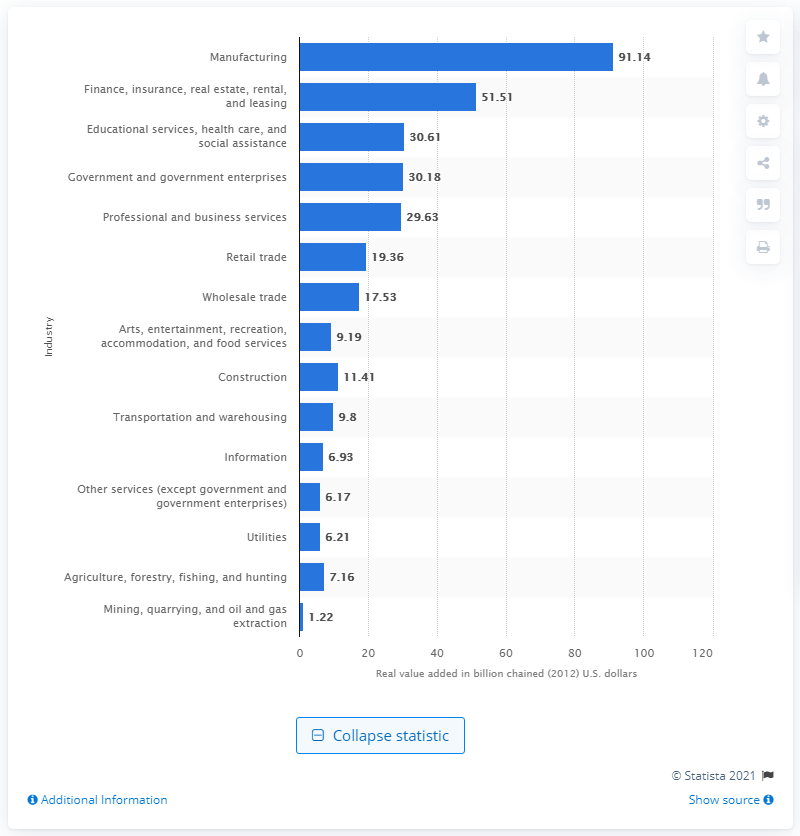Identify some key points in this picture. In 2012, the construction industry contributed a significant amount to the gross domestic product (GDP) of Indiana, amounting to 11.41. 